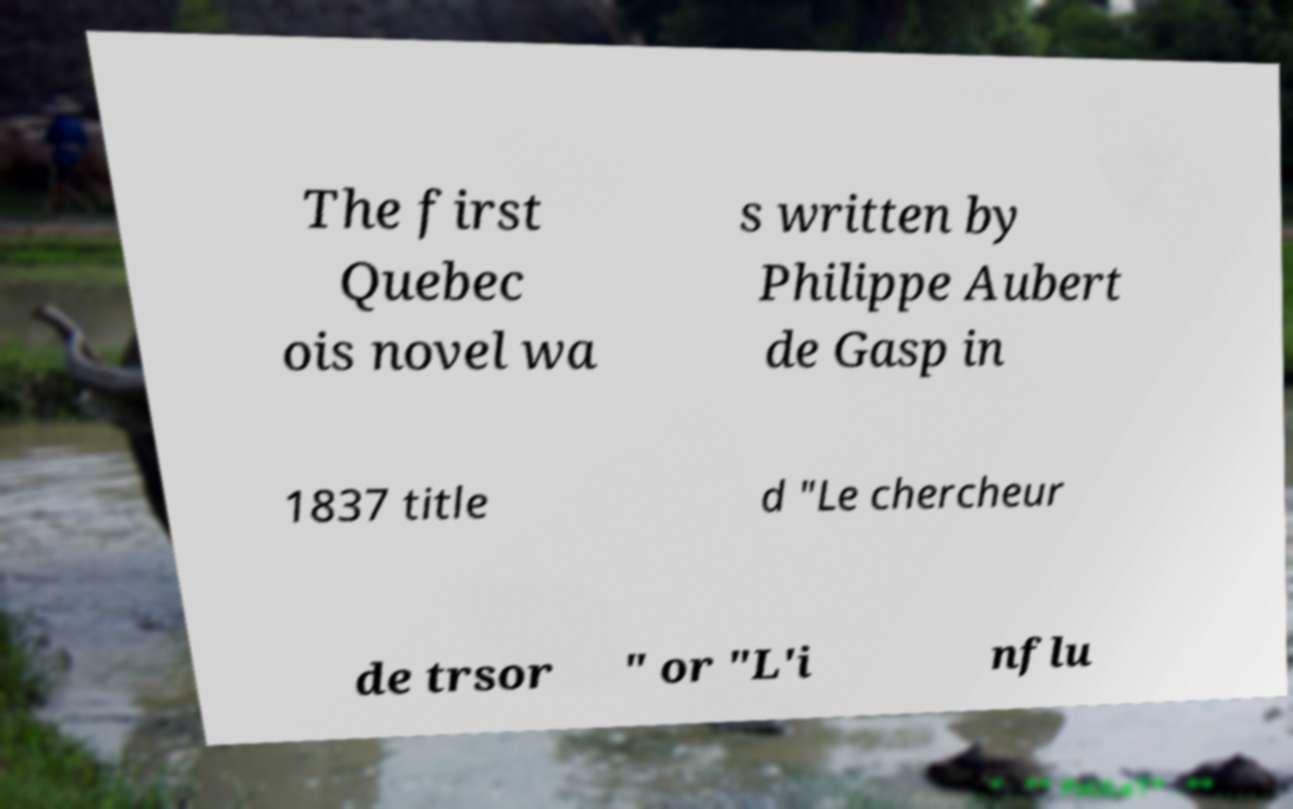Could you assist in decoding the text presented in this image and type it out clearly? The first Quebec ois novel wa s written by Philippe Aubert de Gasp in 1837 title d "Le chercheur de trsor " or "L'i nflu 